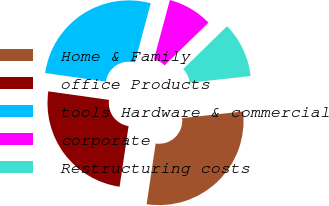Convert chart to OTSL. <chart><loc_0><loc_0><loc_500><loc_500><pie_chart><fcel>Home & Family<fcel>office Products<fcel>tools Hardware & commercial<fcel>corporate<fcel>Restructuring costs<nl><fcel>29.07%<fcel>24.89%<fcel>26.94%<fcel>8.53%<fcel>10.58%<nl></chart> 